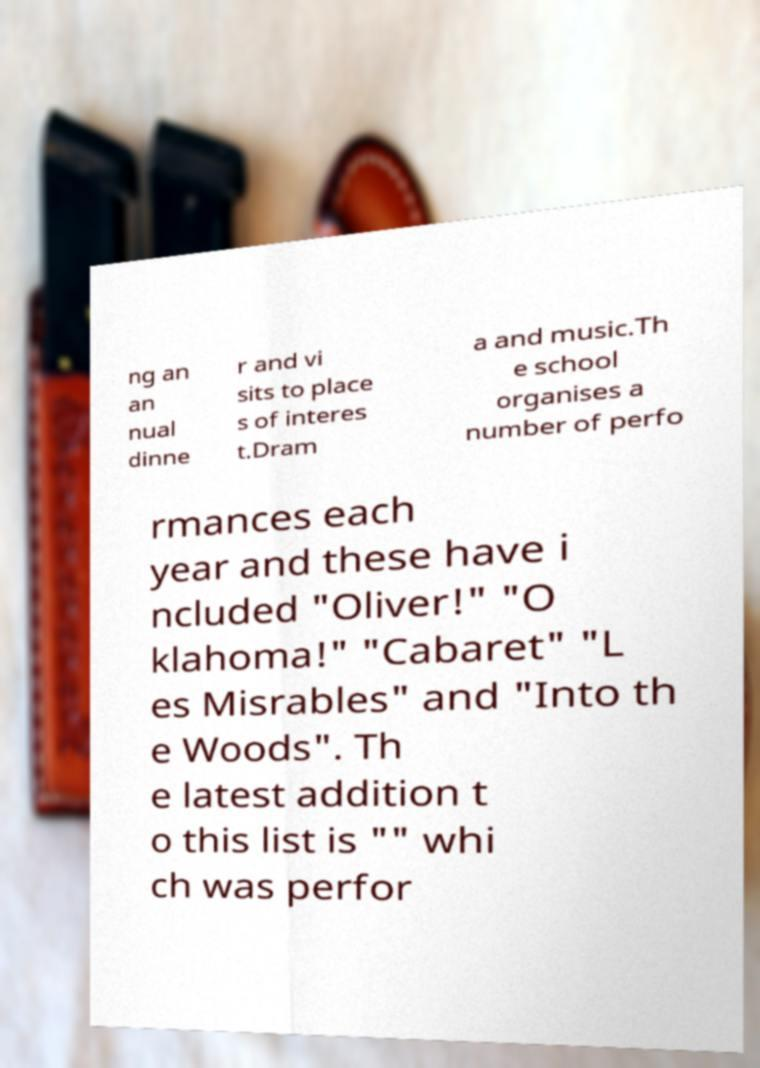For documentation purposes, I need the text within this image transcribed. Could you provide that? ng an an nual dinne r and vi sits to place s of interes t.Dram a and music.Th e school organises a number of perfo rmances each year and these have i ncluded "Oliver!" "O klahoma!" "Cabaret" "L es Misrables" and "Into th e Woods". Th e latest addition t o this list is "" whi ch was perfor 